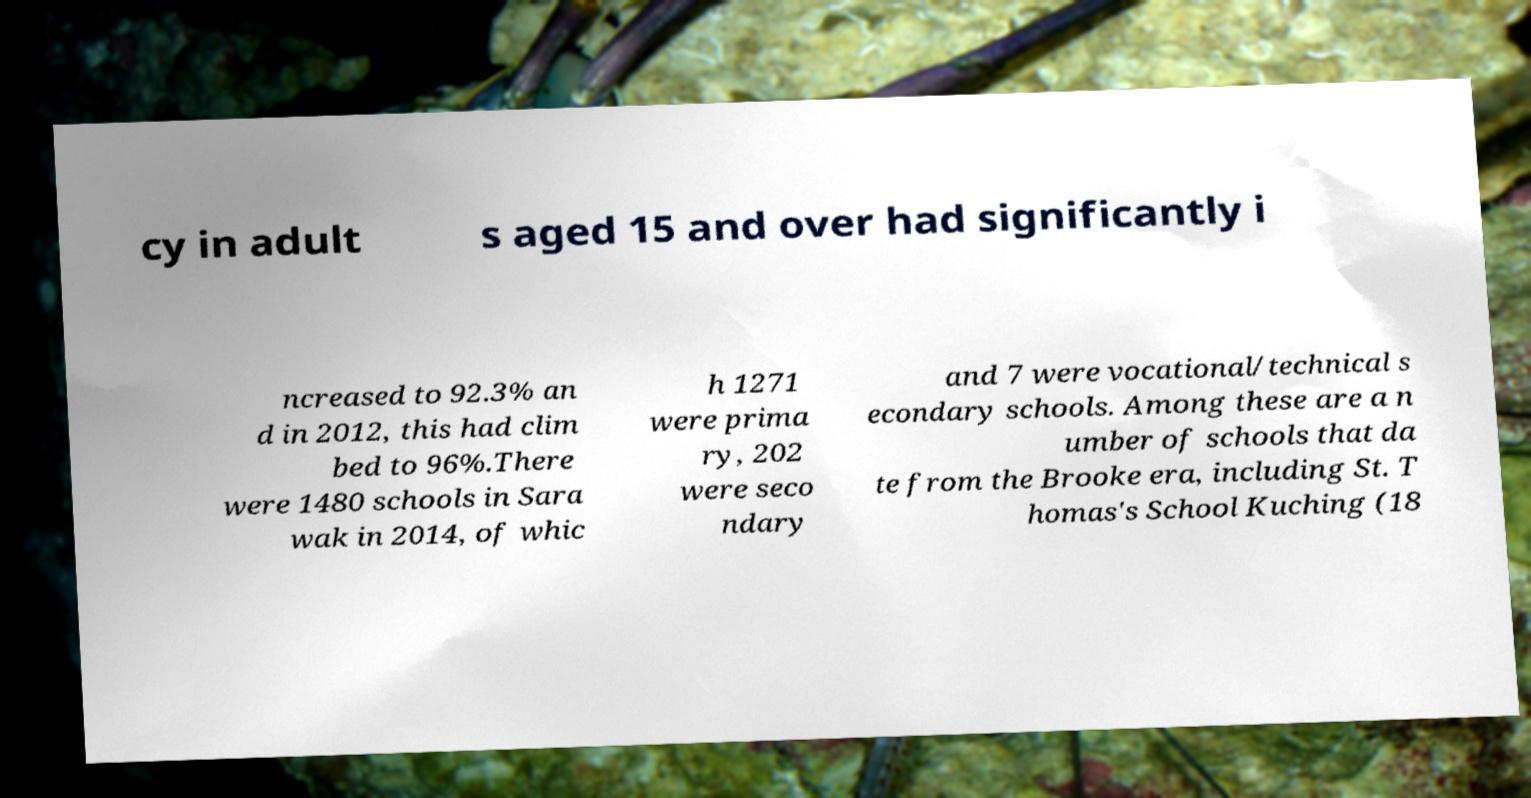Can you accurately transcribe the text from the provided image for me? cy in adult s aged 15 and over had significantly i ncreased to 92.3% an d in 2012, this had clim bed to 96%.There were 1480 schools in Sara wak in 2014, of whic h 1271 were prima ry, 202 were seco ndary and 7 were vocational/technical s econdary schools. Among these are a n umber of schools that da te from the Brooke era, including St. T homas's School Kuching (18 